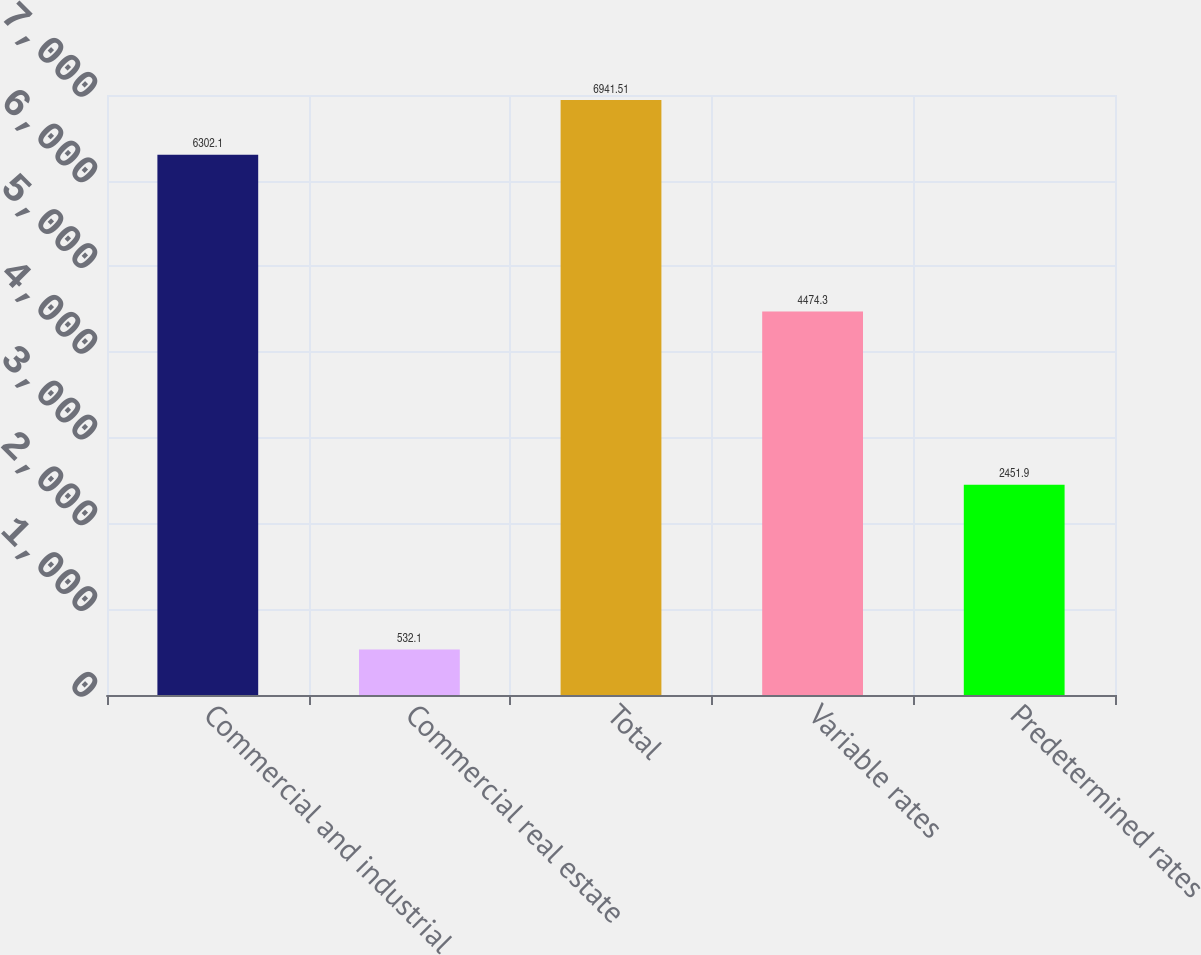Convert chart. <chart><loc_0><loc_0><loc_500><loc_500><bar_chart><fcel>Commercial and industrial<fcel>Commercial real estate<fcel>Total<fcel>Variable rates<fcel>Predetermined rates<nl><fcel>6302.1<fcel>532.1<fcel>6941.51<fcel>4474.3<fcel>2451.9<nl></chart> 